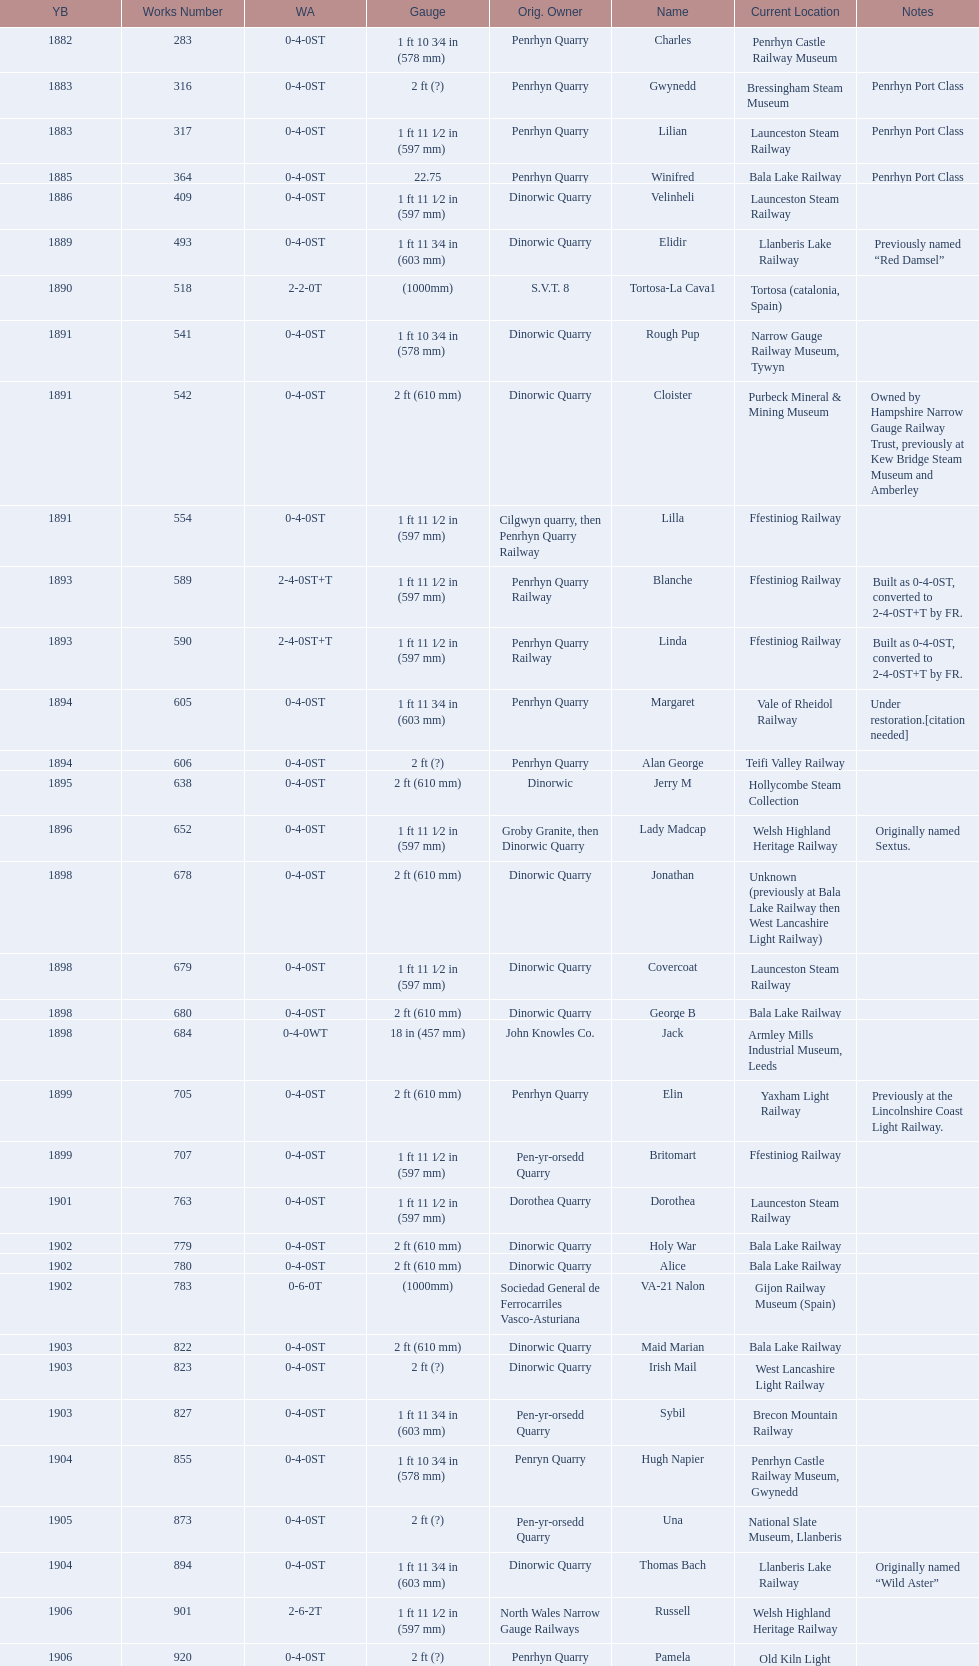What is the works number of the only item built in 1882? 283. 